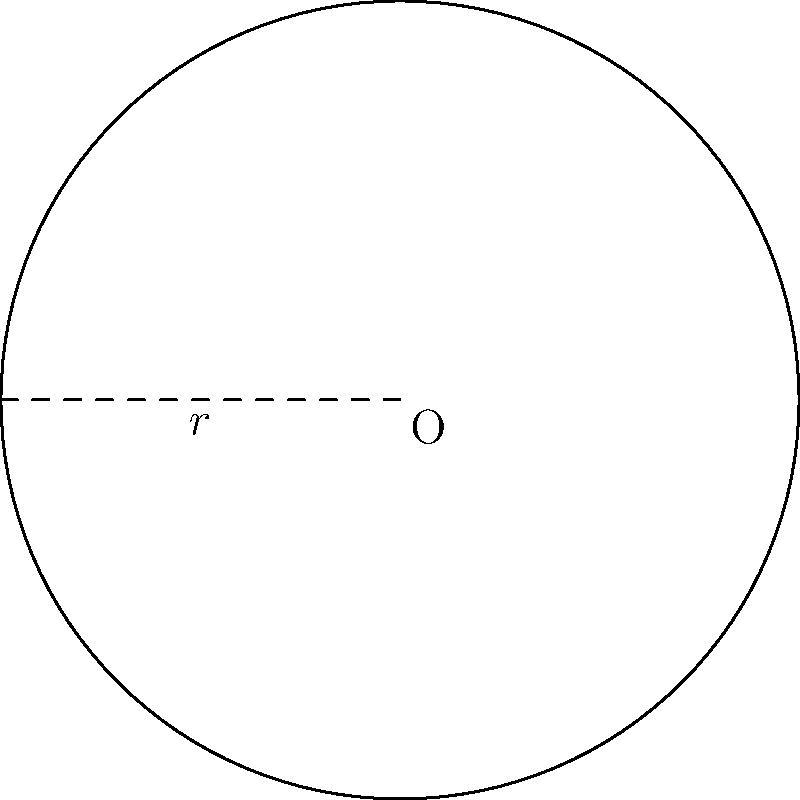You've designed a circular pasture for your sheep to graze safely away from potential wolf encounters. If the radius of this pasture is 50 meters, what is its total area in square meters? Use $\pi \approx 3.14$ for your calculations. To find the area of a circular pasture, we can use the formula for the area of a circle:

$$A = \pi r^2$$

Where:
$A$ = Area of the circle
$\pi$ = Pi (approximately 3.14)
$r$ = Radius of the circle

Given:
- Radius (r) = 50 meters
- $\pi \approx 3.14$

Let's calculate:

1) Substitute the values into the formula:
   $$A = 3.14 \times 50^2$$

2) Calculate the square of the radius:
   $$A = 3.14 \times 2500$$

3) Multiply:
   $$A = 7850$$

Therefore, the area of the circular pasture is 7850 square meters.
Answer: 7850 square meters 